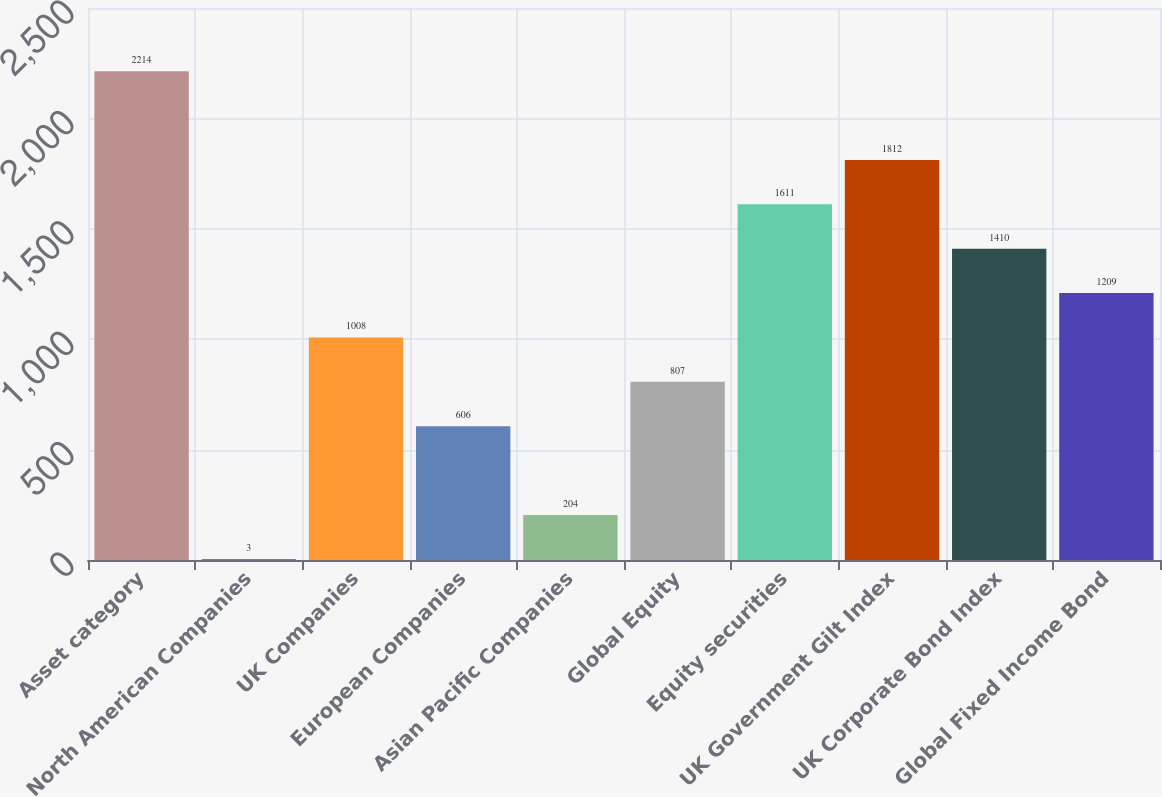<chart> <loc_0><loc_0><loc_500><loc_500><bar_chart><fcel>Asset category<fcel>North American Companies<fcel>UK Companies<fcel>European Companies<fcel>Asian Pacific Companies<fcel>Global Equity<fcel>Equity securities<fcel>UK Government Gilt Index<fcel>UK Corporate Bond Index<fcel>Global Fixed Income Bond<nl><fcel>2214<fcel>3<fcel>1008<fcel>606<fcel>204<fcel>807<fcel>1611<fcel>1812<fcel>1410<fcel>1209<nl></chart> 